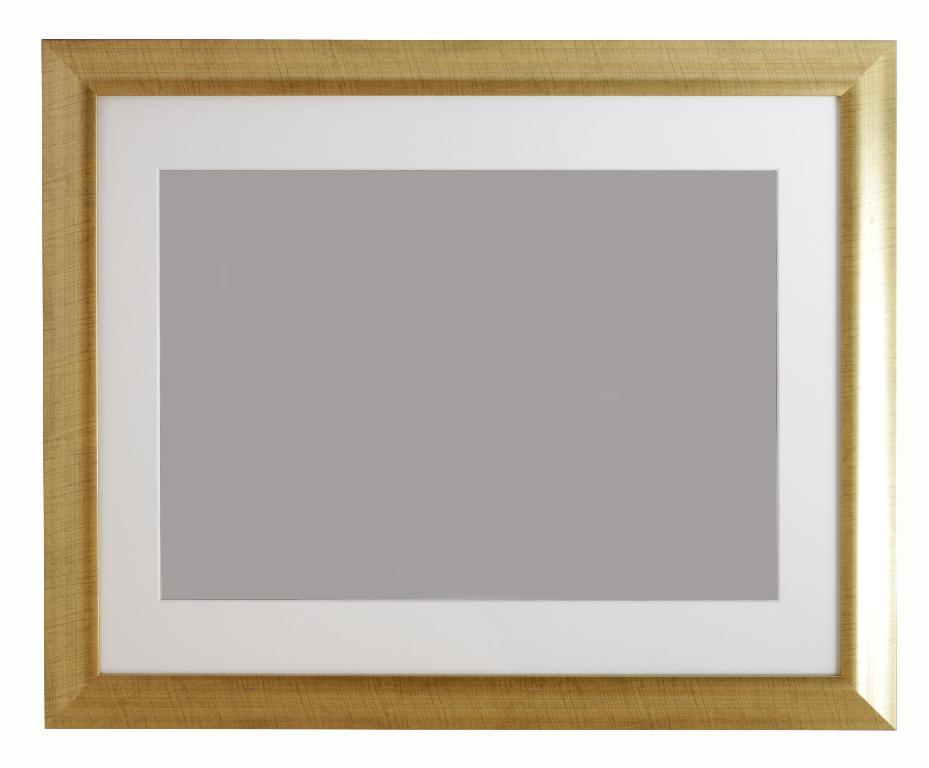What type of object is in the center of the image? There is a wooden photo frame in the center of the image. Can you describe the material of the object in the image? The wooden photo frame is made of wood. How many flowers are growing on the sidewalk in the image? There are no flowers or sidewalks present in the image; it only features a wooden photo frame. 